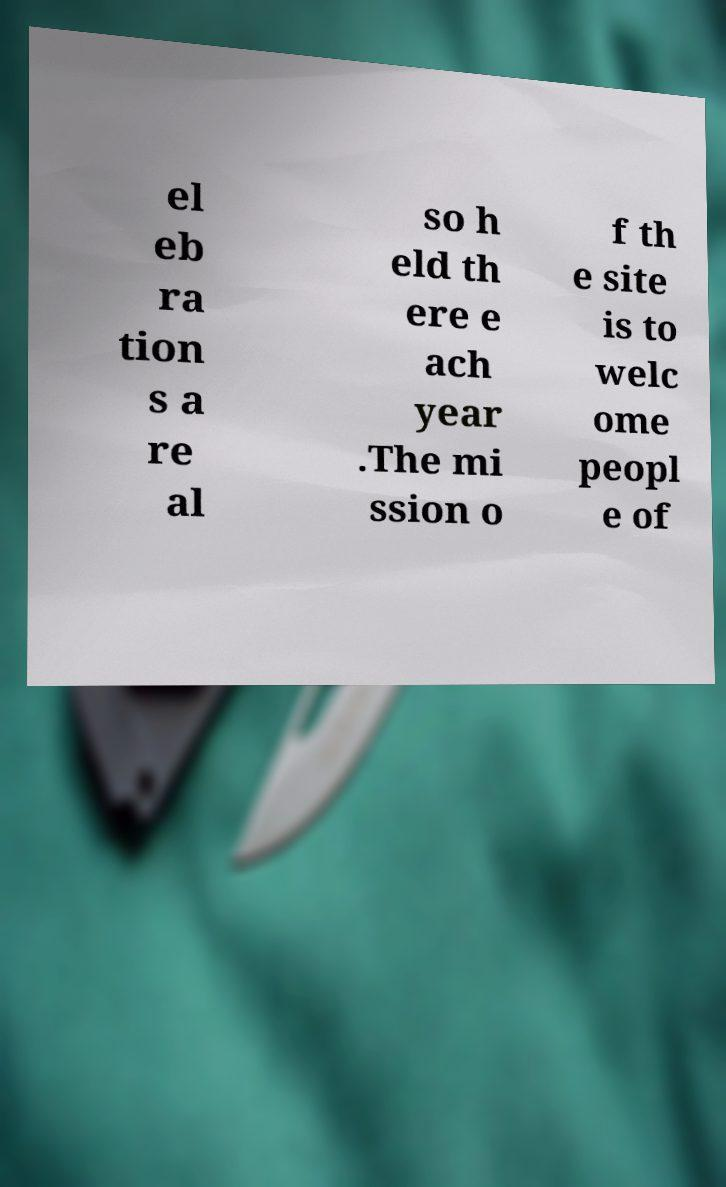Can you read and provide the text displayed in the image?This photo seems to have some interesting text. Can you extract and type it out for me? el eb ra tion s a re al so h eld th ere e ach year .The mi ssion o f th e site is to welc ome peopl e of 